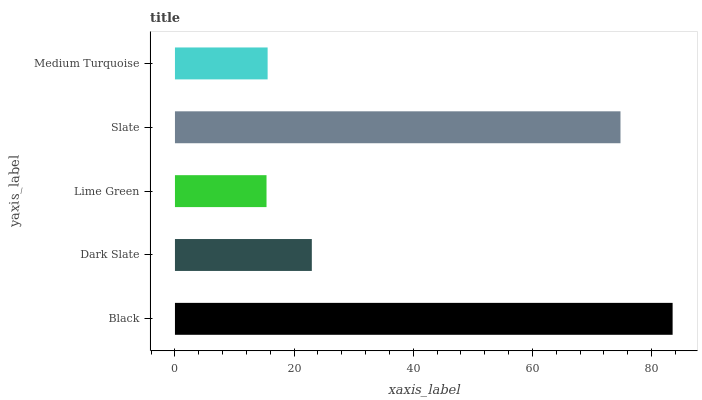Is Lime Green the minimum?
Answer yes or no. Yes. Is Black the maximum?
Answer yes or no. Yes. Is Dark Slate the minimum?
Answer yes or no. No. Is Dark Slate the maximum?
Answer yes or no. No. Is Black greater than Dark Slate?
Answer yes or no. Yes. Is Dark Slate less than Black?
Answer yes or no. Yes. Is Dark Slate greater than Black?
Answer yes or no. No. Is Black less than Dark Slate?
Answer yes or no. No. Is Dark Slate the high median?
Answer yes or no. Yes. Is Dark Slate the low median?
Answer yes or no. Yes. Is Slate the high median?
Answer yes or no. No. Is Lime Green the low median?
Answer yes or no. No. 